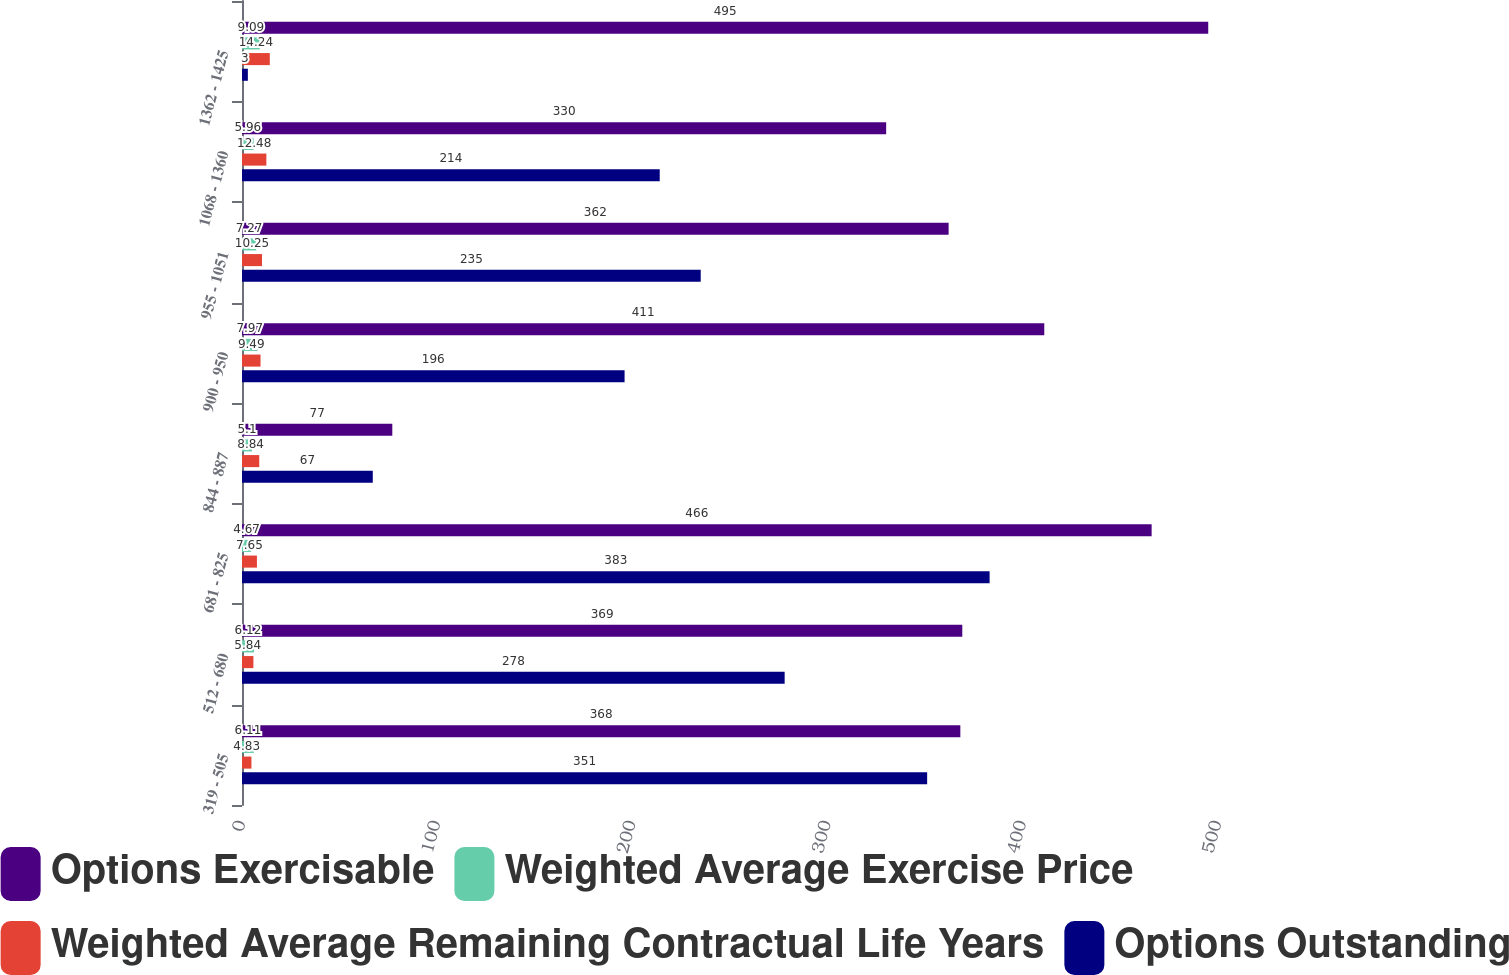Convert chart. <chart><loc_0><loc_0><loc_500><loc_500><stacked_bar_chart><ecel><fcel>319 - 505<fcel>512 - 680<fcel>681 - 825<fcel>844 - 887<fcel>900 - 950<fcel>955 - 1051<fcel>1068 - 1360<fcel>1362 - 1425<nl><fcel>Options Exercisable<fcel>368<fcel>369<fcel>466<fcel>77<fcel>411<fcel>362<fcel>330<fcel>495<nl><fcel>Weighted Average Exercise Price<fcel>6.11<fcel>6.12<fcel>4.67<fcel>5.1<fcel>7.97<fcel>7.27<fcel>5.96<fcel>9.09<nl><fcel>Weighted Average Remaining Contractual Life Years<fcel>4.83<fcel>5.84<fcel>7.65<fcel>8.84<fcel>9.49<fcel>10.25<fcel>12.48<fcel>14.24<nl><fcel>Options Outstanding<fcel>351<fcel>278<fcel>383<fcel>67<fcel>196<fcel>235<fcel>214<fcel>3<nl></chart> 